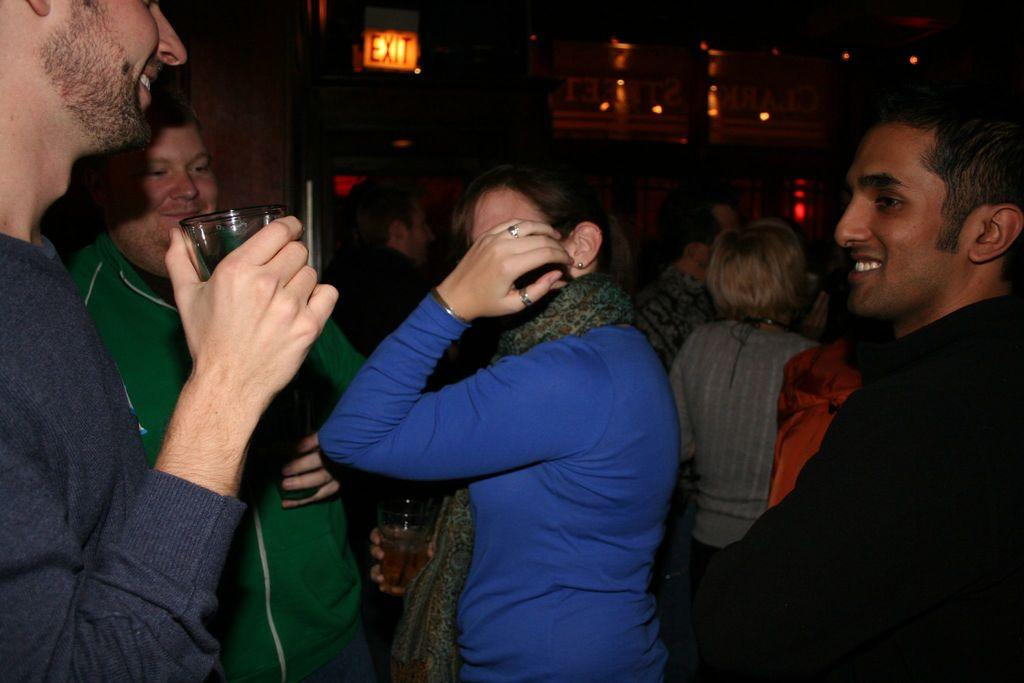How many people are present in the image? There are a few people in the image. What can be seen in the background of the image? There is a wall in the background of the image. What type of objects have text on them in the image? There are boards with text in the image. What can be used to provide illumination in the image? There are lights visible in the image. What type of oatmeal is being served to the boys in the image? There are no boys or oatmeal present in the image. What rule is being enforced by the people in the image? There is no indication of a rule being enforced in the image. 